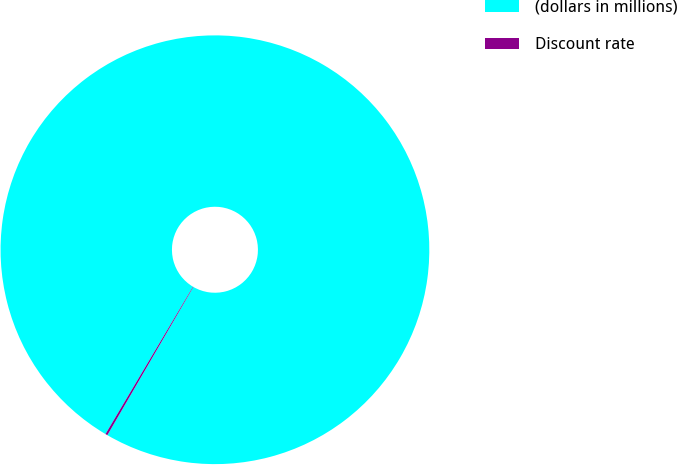Convert chart to OTSL. <chart><loc_0><loc_0><loc_500><loc_500><pie_chart><fcel>(dollars in millions)<fcel>Discount rate<nl><fcel>99.84%<fcel>0.16%<nl></chart> 